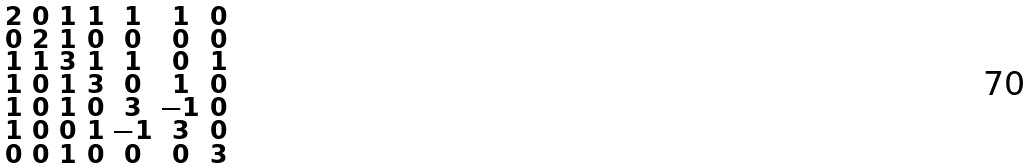<formula> <loc_0><loc_0><loc_500><loc_500>\begin{smallmatrix} 2 & 0 & 1 & 1 & 1 & 1 & 0 \\ 0 & 2 & 1 & 0 & 0 & 0 & 0 \\ 1 & 1 & 3 & 1 & 1 & 0 & 1 \\ 1 & 0 & 1 & 3 & 0 & 1 & 0 \\ 1 & 0 & 1 & 0 & 3 & - 1 & 0 \\ 1 & 0 & 0 & 1 & - 1 & 3 & 0 \\ 0 & 0 & 1 & 0 & 0 & 0 & 3 \end{smallmatrix}</formula> 